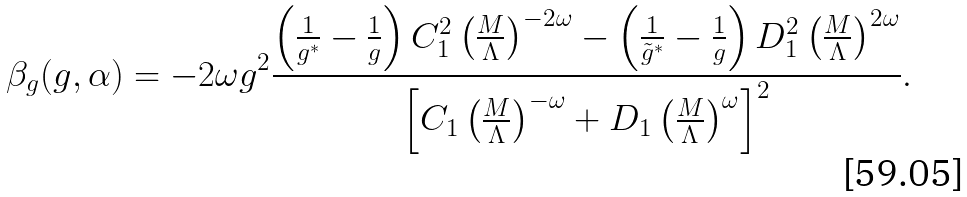Convert formula to latex. <formula><loc_0><loc_0><loc_500><loc_500>\beta _ { g } ( g , \alpha ) = - 2 \omega g ^ { 2 } \frac { \left ( \frac { 1 } { g ^ { * } } - \frac { 1 } { g } \right ) C _ { 1 } ^ { 2 } \left ( \frac { M } { \Lambda } \right ) ^ { - 2 \omega } - \left ( \frac { 1 } { \tilde { g } ^ { * } } - \frac { 1 } { g } \right ) D _ { 1 } ^ { 2 } \left ( \frac { M } { \Lambda } \right ) ^ { 2 \omega } } { \left [ C _ { 1 } \left ( \frac { M } { \Lambda } \right ) ^ { - \omega } + D _ { 1 } \left ( \frac { M } { \Lambda } \right ) ^ { \omega } \right ] ^ { 2 } } .</formula> 